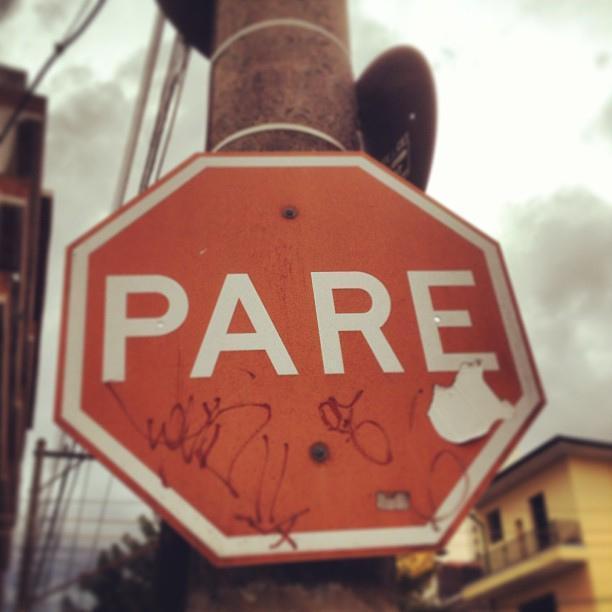How many white airplanes do you see?
Give a very brief answer. 0. 